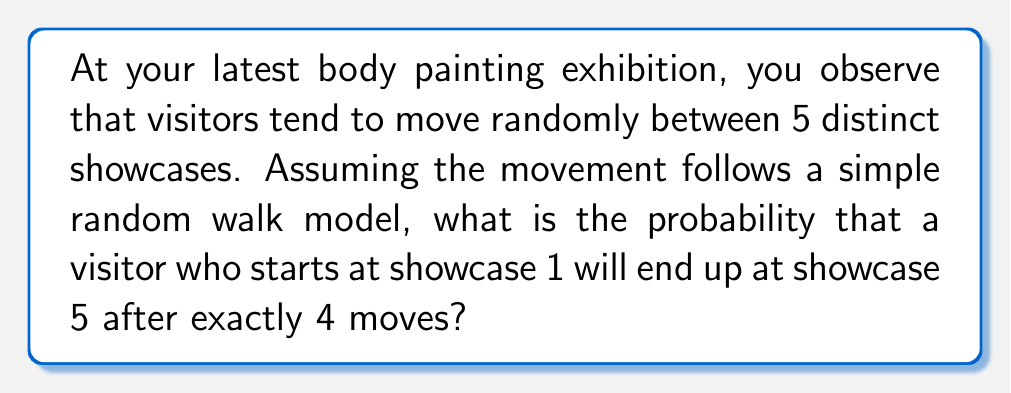Can you answer this question? Let's approach this step-by-step:

1) In a simple random walk on a line with 5 positions, at each step, a visitor has equal probability of moving left or right (except at the ends where they can only move in one direction).

2) We need to find the probability of being at position 5 after 4 steps, starting from position 1.

3) To reach position 5 from position 1 in exactly 4 steps, the visitor must make 4 steps to the right and 0 steps to the left.

4) The probability of this specific path is:

   $P(\text{4 right, 0 left}) = (\frac{1}{2})^4 = \frac{1}{16}$

5) However, this is not the only way to reach position 5 in 4 steps. The visitor could also make:
   - 3 steps right, 1 step left, 2 steps right
   - 2 steps right, 1 step left, 3 steps right
   - 2 steps right, 2 steps left, 4 steps right

6) We need to count these possibilities. This is a combination problem. We need to choose 2 positions out of 4 for the right moves (the other 2 will be left moves).

7) The number of ways to choose 2 positions out of 4 is given by the combination formula:

   $$\binom{4}{2} = \frac{4!}{2!(4-2)!} = \frac{4 \cdot 3}{2 \cdot 1} = 6$$

8) Each of these 6 paths has a probability of $(\frac{1}{2})^4 = \frac{1}{16}$

9) Therefore, the total probability is:

   $$P(\text{reach 5 in 4 steps}) = 6 \cdot \frac{1}{16} = \frac{3}{8} = 0.375$$
Answer: $\frac{3}{8}$ or 0.375 